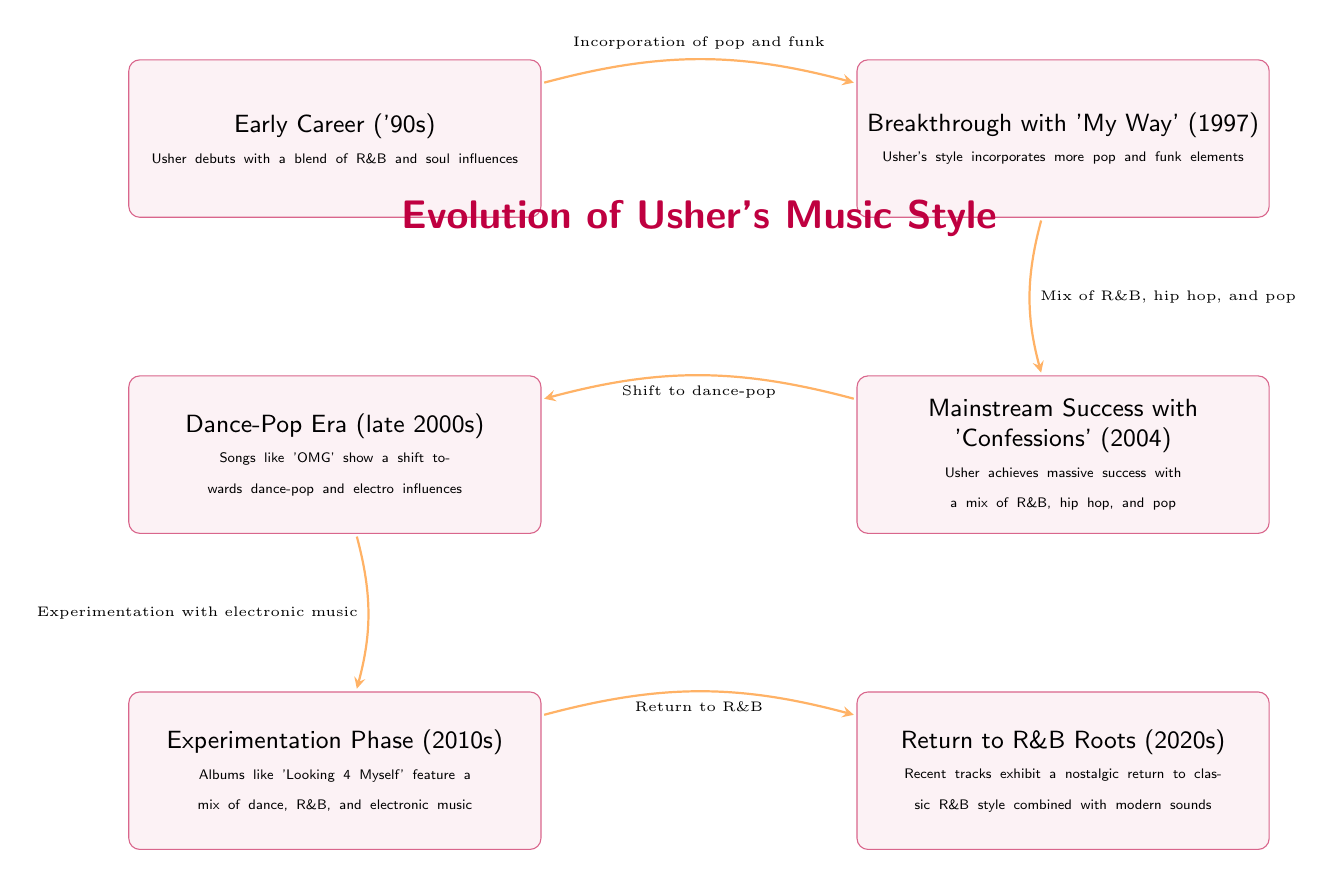What is the starting point of Usher's musical evolution in this diagram? The starting point is the node labeled "Early Career ('90s)", which indicates Usher's initial music style.
Answer: Early Career ('90s) How many nodes are there in the diagram? Counting the labeled boxes represents different stages of Usher's music evolution, resulting in a total of six nodes.
Answer: 6 What was Usher's breakthrough album? The label "Breakthrough with 'My Way' (1997)" in the diagram directly indicates this significant album in his career.
Answer: My Way (1997) Which music style does Usher return to in the 2020s? The node labeled "Return to R&B Roots (2020s)" explicitly states that Usher returns to classic R&B style.
Answer: R&B What is the relationship between "Mainstream Success with 'Confessions' (2004)" and "Dance-Pop Era (late 2000s)"? The arrow between these two nodes shows that Usher's success in "Confessions" led to a "Shift to dance-pop".
Answer: Shift to dance-pop What elements were incorporated in Usher's style during the breakthrough with 'My Way'? The diagram notes "Incorporation of pop and funk" as the transition from the early career to the breakthrough stage, indicating a blend of these genres.
Answer: Pop and funk What genre evolution is represented from "Dance-Pop Era (late 2000s)" to "Experimentation Phase (2010s)"? The diagram points to "Experimentation with electronic music", signifying a shift in Usher's style towards incorporating electronic music influences.
Answer: Electronic music What was a significant aspect of the "Experimentation Phase (2010s)"? The node describes this phase as featuring a mix of various styles, particularly noting dance, R&B, and electronic music in Usher's albums.
Answer: Mix of dance, R&B, and electronic music Which direction does the arrow from "Breakthrough with 'My Way' (1997)" to "Mainstream Success with 'Confessions' (2004)" indicate? The arrow demonstrates a forward progression from the breakthrough album towards mainstream success, showing the growth in Usher's music style.
Answer: Forward progression 